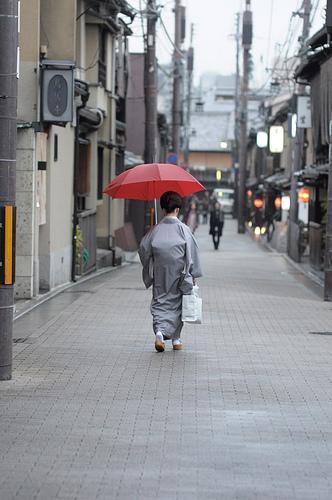What is the red thing?
Give a very brief answer. Umbrella. What is she holding over her head?
Be succinct. Umbrella. Is the lady all wet?
Be succinct. No. Is the street paved?
Concise answer only. Yes. 